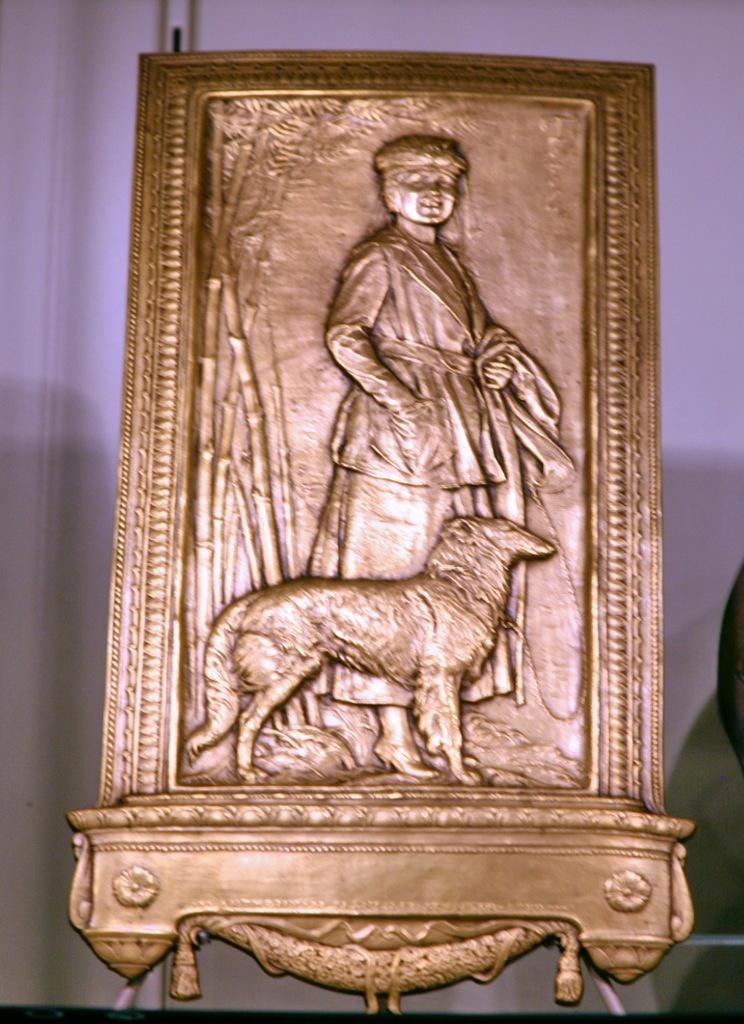In one or two sentences, can you explain what this image depicts? There is a golden frame in the foreground area of the image, it seems like a wall in the background. 